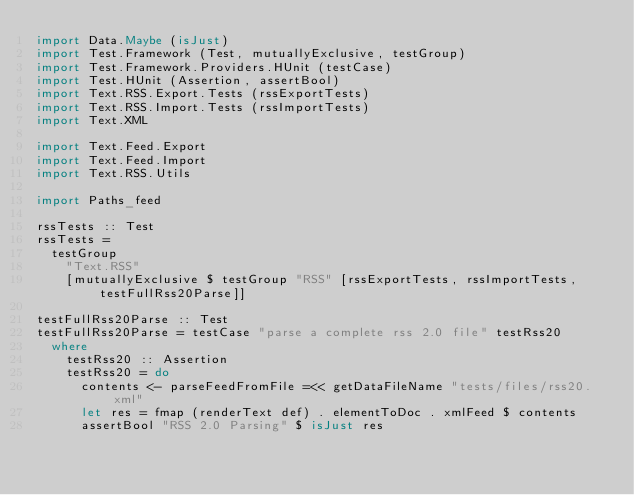<code> <loc_0><loc_0><loc_500><loc_500><_Haskell_>import Data.Maybe (isJust)
import Test.Framework (Test, mutuallyExclusive, testGroup)
import Test.Framework.Providers.HUnit (testCase)
import Test.HUnit (Assertion, assertBool)
import Text.RSS.Export.Tests (rssExportTests)
import Text.RSS.Import.Tests (rssImportTests)
import Text.XML

import Text.Feed.Export
import Text.Feed.Import
import Text.RSS.Utils

import Paths_feed

rssTests :: Test
rssTests =
  testGroup
    "Text.RSS"
    [mutuallyExclusive $ testGroup "RSS" [rssExportTests, rssImportTests, testFullRss20Parse]]

testFullRss20Parse :: Test
testFullRss20Parse = testCase "parse a complete rss 2.0 file" testRss20
  where
    testRss20 :: Assertion
    testRss20 = do
      contents <- parseFeedFromFile =<< getDataFileName "tests/files/rss20.xml"
      let res = fmap (renderText def) . elementToDoc . xmlFeed $ contents
      assertBool "RSS 2.0 Parsing" $ isJust res
</code> 